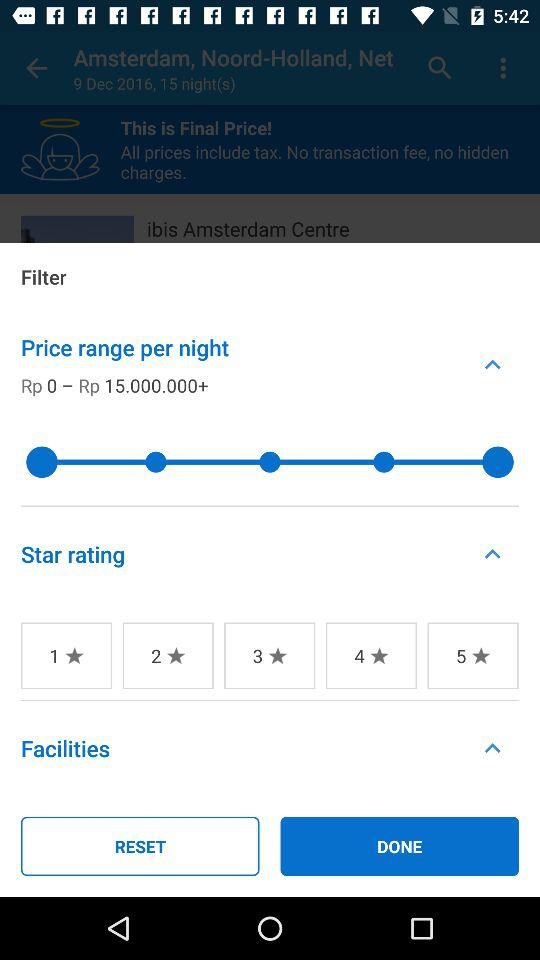What is the price range of the hotels?
Answer the question using a single word or phrase. Rp 0 - Rp 15.000.000+ 